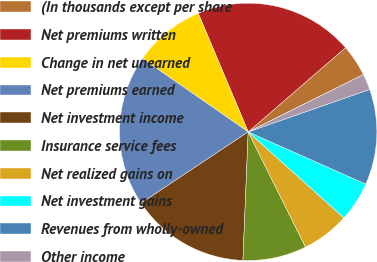<chart> <loc_0><loc_0><loc_500><loc_500><pie_chart><fcel>(In thousands except per share<fcel>Net premiums written<fcel>Change in net unearned<fcel>Net premiums earned<fcel>Net investment income<fcel>Insurance service fees<fcel>Net realized gains on<fcel>Net investment gains<fcel>Revenues from wholly-owned<fcel>Other income<nl><fcel>4.0%<fcel>20.0%<fcel>9.0%<fcel>19.0%<fcel>15.0%<fcel>8.0%<fcel>6.0%<fcel>5.0%<fcel>12.0%<fcel>2.0%<nl></chart> 